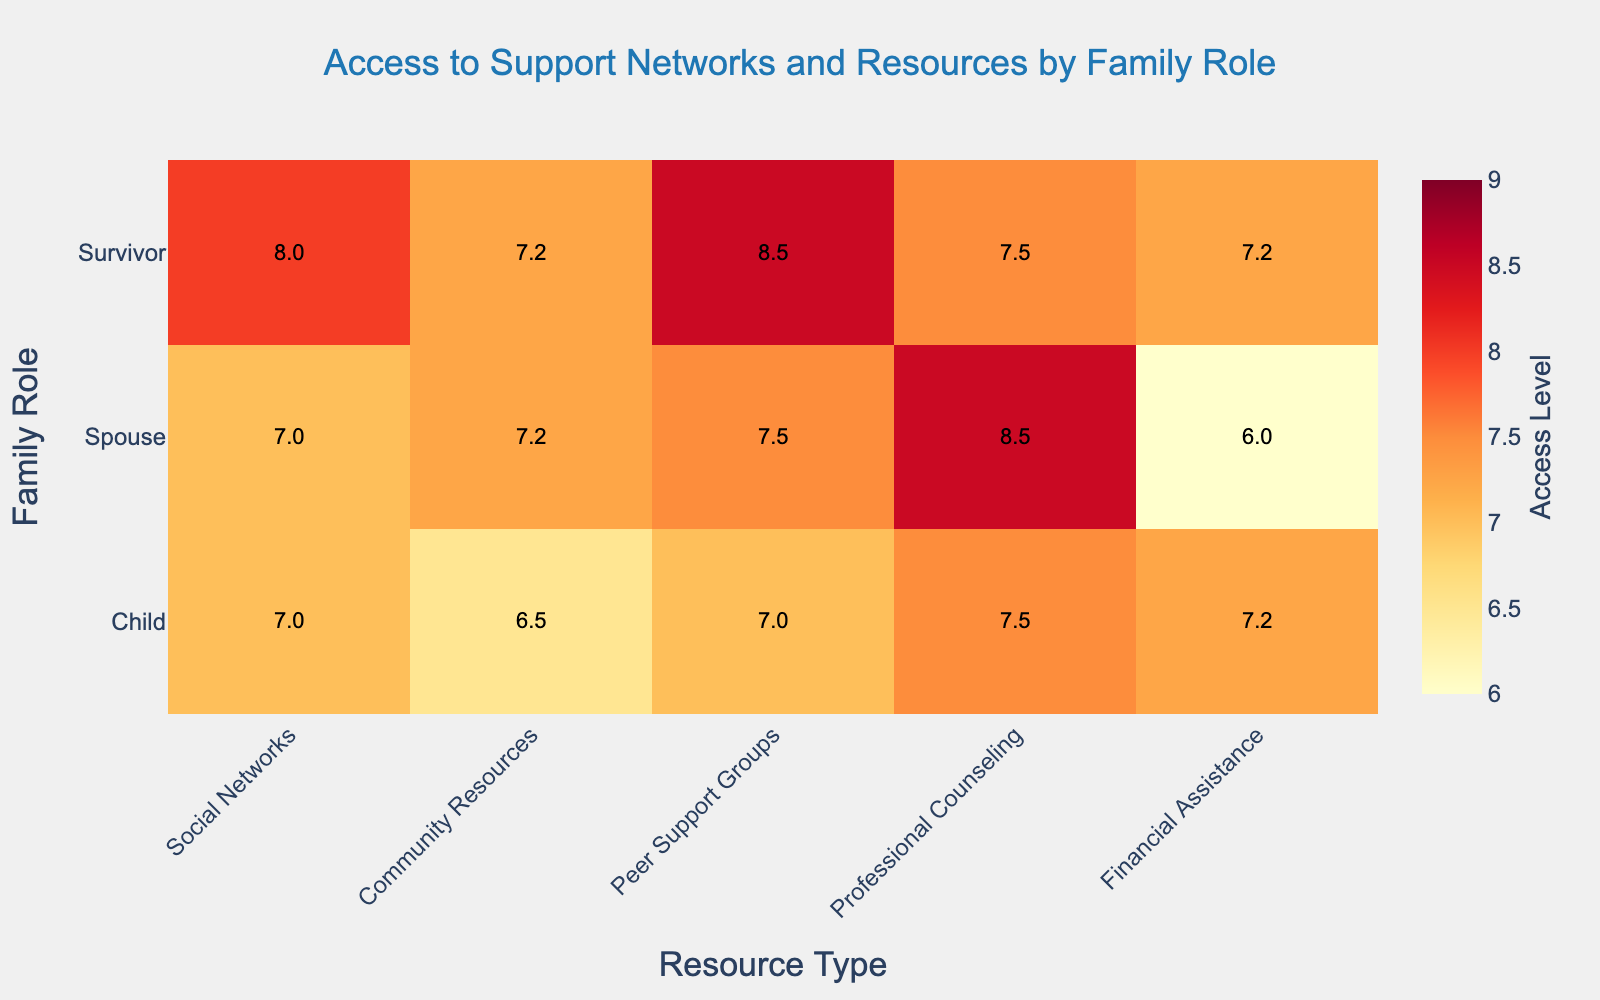What is the title of the heatmap? The title is located at the top center of the heatmap, and it reads "Access to Support Networks and Resources by Family Role".
Answer: Access to Support Networks and Resources by Family Role Which resource has the highest access level for survivors? From the heatmap under "Survivor" row, the color intensity and annotation indicate "Peer Support Groups" has the highest average value of 8.5.
Answer: Peer Support Groups In which family role do professional counseling and community resources have the same access level? Look at the values for both "Professional Counseling" and "Community Resources" columns across different family roles, and check which ones match. For the "Child" role, both are at 7.5.
Answer: Child What is the difference between the highest and lowest access levels for spouses? For spouses, the highest access level is Professional Counseling at 8.5, and the lowest is Financial Assistance at 6.2. The difference is calculated as 8.5 - 6.2 = 2.3.
Answer: 2.3 Which family role has the least access to social networks? The "Social Networks" column should be observed for all family roles; the "Child" role has the lowest value at 7.0.
Answer: Child Compare the average access levels to financial assistance between survivors and spouses. Which one is higher, and by how much? Calculate the averages for "Financial Assistance" under "Survivor" (7.25) and "Spouse" (6.0). The difference is 7.25 - 6.0 = 1.25, so survivors have higher access by 1.25.
Answer: Survivors by 1.25 Which family role has the most uniform access levels across all resources? Look at the variance in the access levels for each family role. "Child" has the most consistent values ranging from 7.0 to 7.7, showing the least variance.
Answer: Child What is the overall average access level for all resources for family roles combined? Sum all the average values from each family role and then divide by the number of values. The calculation is ((7.75+7.25+8.5+7.5+7.25) + (7.25+7.25+7.5+8.5+6.0) + (7.0+7.0+7.0+7.7+7.0))/15 = 7.4.
Answer: 7.4 